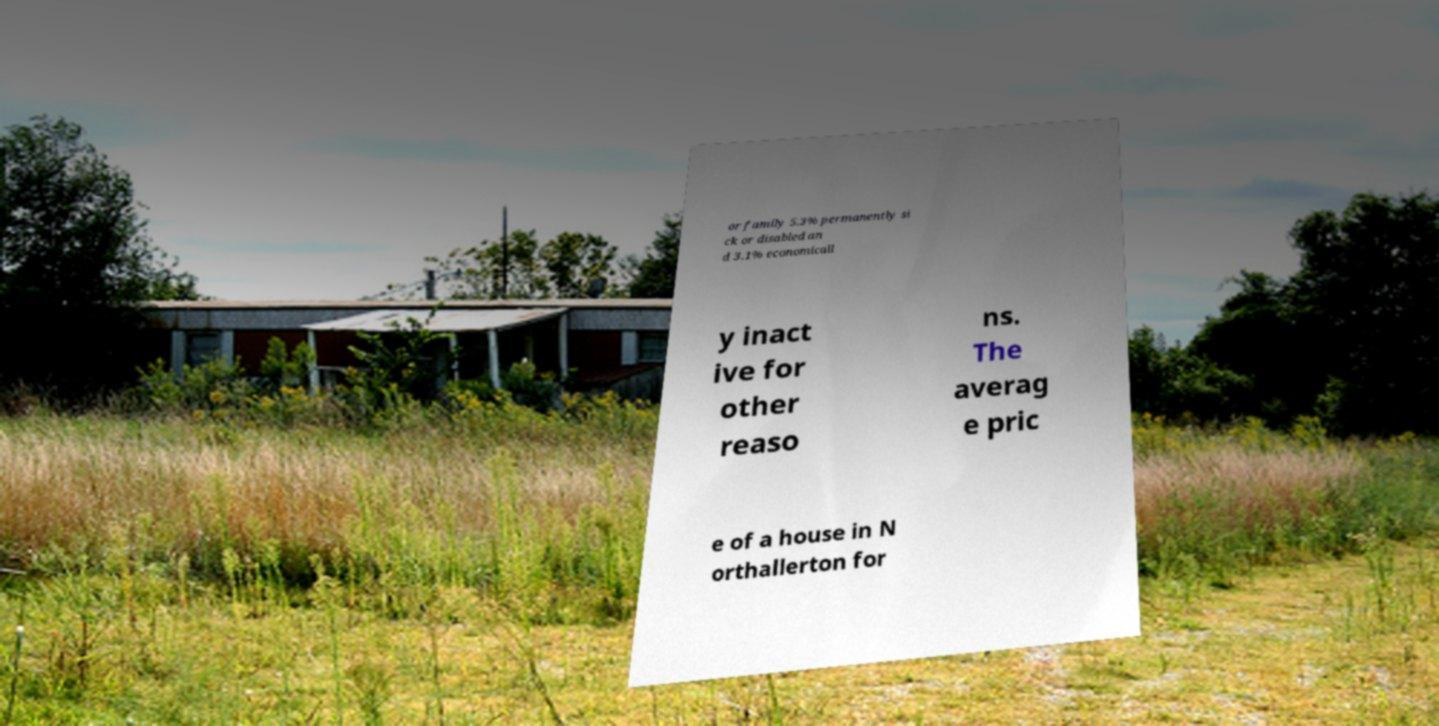Can you read and provide the text displayed in the image?This photo seems to have some interesting text. Can you extract and type it out for me? or family 5.3% permanently si ck or disabled an d 3.1% economicall y inact ive for other reaso ns. The averag e pric e of a house in N orthallerton for 